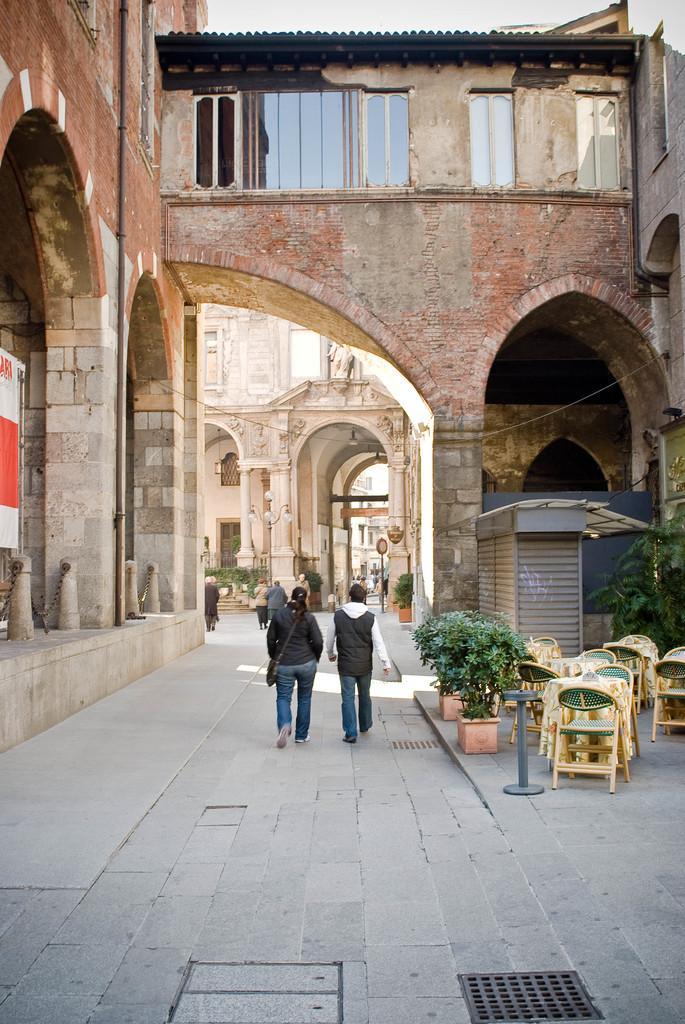Can you describe this image briefly? In this image i can see a woman and a man walking on road at right i can see a plant, few chairs, a table at the back ground i can see a pole, a wall and a shed. 